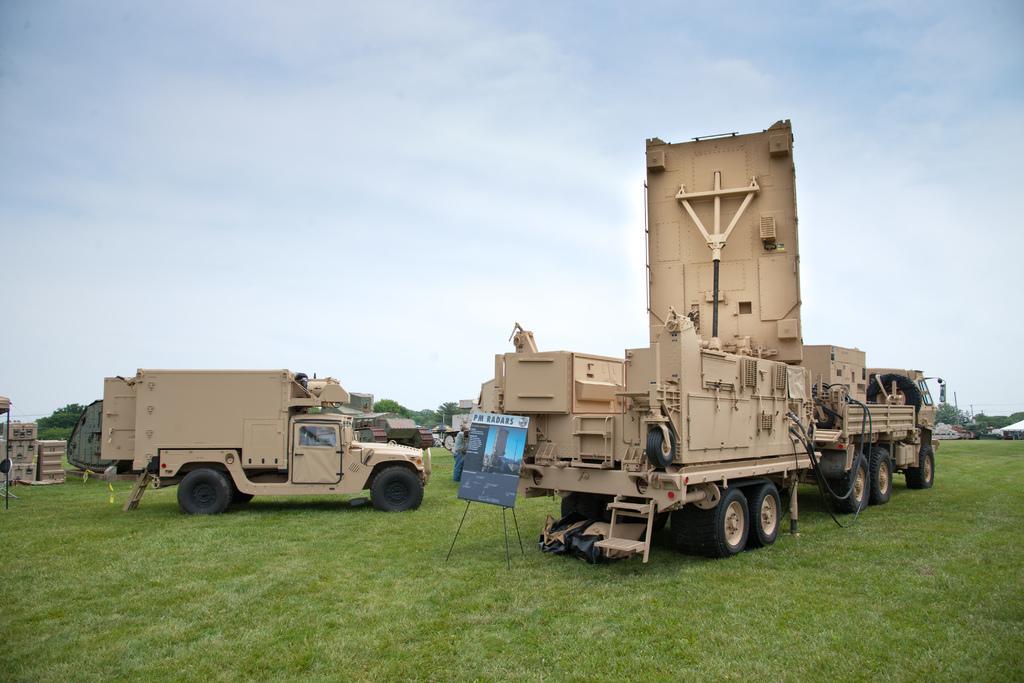Can you describe this image briefly? In the foreground of this image, there are two vehicles on the grass and also a board. On the left, there are cream colored objects. In the background, there is a house, tents, trees, few vehicles and the sky. 